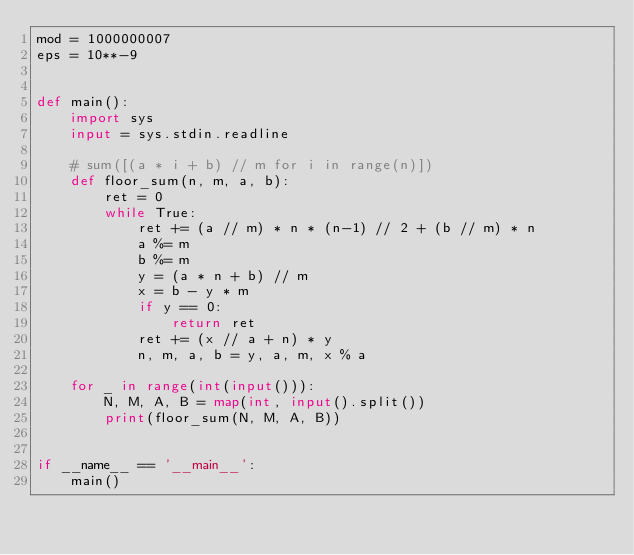<code> <loc_0><loc_0><loc_500><loc_500><_Python_>mod = 1000000007
eps = 10**-9


def main():
    import sys
    input = sys.stdin.readline

    # sum([(a * i + b) // m for i in range(n)])
    def floor_sum(n, m, a, b):
        ret = 0
        while True:
            ret += (a // m) * n * (n-1) // 2 + (b // m) * n
            a %= m
            b %= m
            y = (a * n + b) // m
            x = b - y * m
            if y == 0:
                return ret
            ret += (x // a + n) * y
            n, m, a, b = y, a, m, x % a

    for _ in range(int(input())):
        N, M, A, B = map(int, input().split())
        print(floor_sum(N, M, A, B))


if __name__ == '__main__':
    main()
</code> 